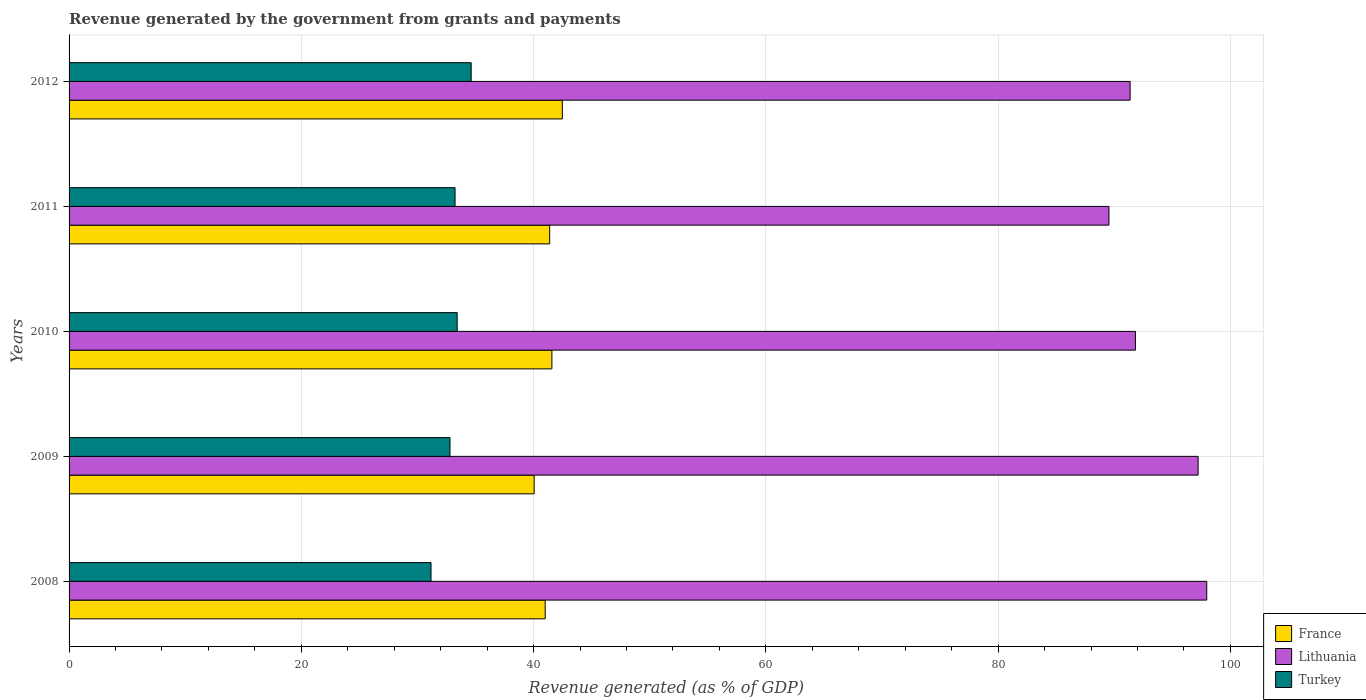How many groups of bars are there?
Give a very brief answer. 5. Are the number of bars per tick equal to the number of legend labels?
Give a very brief answer. Yes. Are the number of bars on each tick of the Y-axis equal?
Ensure brevity in your answer.  Yes. How many bars are there on the 5th tick from the top?
Offer a terse response. 3. What is the label of the 4th group of bars from the top?
Offer a terse response. 2009. In how many cases, is the number of bars for a given year not equal to the number of legend labels?
Keep it short and to the point. 0. What is the revenue generated by the government in France in 2010?
Offer a terse response. 41.57. Across all years, what is the maximum revenue generated by the government in Turkey?
Offer a very short reply. 34.62. Across all years, what is the minimum revenue generated by the government in Turkey?
Ensure brevity in your answer.  31.17. In which year was the revenue generated by the government in France maximum?
Your answer should be very brief. 2012. What is the total revenue generated by the government in Lithuania in the graph?
Give a very brief answer. 467.91. What is the difference between the revenue generated by the government in Lithuania in 2009 and that in 2011?
Ensure brevity in your answer.  7.68. What is the difference between the revenue generated by the government in Turkey in 2009 and the revenue generated by the government in Lithuania in 2011?
Provide a short and direct response. -56.74. What is the average revenue generated by the government in Turkey per year?
Make the answer very short. 33.05. In the year 2012, what is the difference between the revenue generated by the government in Lithuania and revenue generated by the government in Turkey?
Offer a terse response. 56.74. What is the ratio of the revenue generated by the government in Turkey in 2010 to that in 2012?
Make the answer very short. 0.97. What is the difference between the highest and the second highest revenue generated by the government in France?
Offer a terse response. 0.9. What is the difference between the highest and the lowest revenue generated by the government in France?
Your response must be concise. 2.43. In how many years, is the revenue generated by the government in Lithuania greater than the average revenue generated by the government in Lithuania taken over all years?
Make the answer very short. 2. What does the 2nd bar from the bottom in 2011 represents?
Your answer should be very brief. Lithuania. How many bars are there?
Offer a very short reply. 15. Are all the bars in the graph horizontal?
Make the answer very short. Yes. How many years are there in the graph?
Offer a terse response. 5. Where does the legend appear in the graph?
Give a very brief answer. Bottom right. What is the title of the graph?
Provide a succinct answer. Revenue generated by the government from grants and payments. Does "Nepal" appear as one of the legend labels in the graph?
Keep it short and to the point. No. What is the label or title of the X-axis?
Offer a terse response. Revenue generated (as % of GDP). What is the label or title of the Y-axis?
Provide a succinct answer. Years. What is the Revenue generated (as % of GDP) of France in 2008?
Provide a succinct answer. 41. What is the Revenue generated (as % of GDP) in Lithuania in 2008?
Your answer should be very brief. 97.96. What is the Revenue generated (as % of GDP) of Turkey in 2008?
Ensure brevity in your answer.  31.17. What is the Revenue generated (as % of GDP) in France in 2009?
Provide a succinct answer. 40.05. What is the Revenue generated (as % of GDP) in Lithuania in 2009?
Offer a very short reply. 97.22. What is the Revenue generated (as % of GDP) in Turkey in 2009?
Provide a short and direct response. 32.8. What is the Revenue generated (as % of GDP) in France in 2010?
Offer a terse response. 41.57. What is the Revenue generated (as % of GDP) in Lithuania in 2010?
Offer a very short reply. 91.82. What is the Revenue generated (as % of GDP) of Turkey in 2010?
Give a very brief answer. 33.42. What is the Revenue generated (as % of GDP) of France in 2011?
Provide a succinct answer. 41.38. What is the Revenue generated (as % of GDP) in Lithuania in 2011?
Ensure brevity in your answer.  89.54. What is the Revenue generated (as % of GDP) in Turkey in 2011?
Offer a terse response. 33.23. What is the Revenue generated (as % of GDP) in France in 2012?
Offer a very short reply. 42.47. What is the Revenue generated (as % of GDP) of Lithuania in 2012?
Provide a short and direct response. 91.36. What is the Revenue generated (as % of GDP) in Turkey in 2012?
Provide a short and direct response. 34.62. Across all years, what is the maximum Revenue generated (as % of GDP) of France?
Your answer should be compact. 42.47. Across all years, what is the maximum Revenue generated (as % of GDP) in Lithuania?
Make the answer very short. 97.96. Across all years, what is the maximum Revenue generated (as % of GDP) in Turkey?
Your response must be concise. 34.62. Across all years, what is the minimum Revenue generated (as % of GDP) in France?
Your answer should be very brief. 40.05. Across all years, what is the minimum Revenue generated (as % of GDP) in Lithuania?
Make the answer very short. 89.54. Across all years, what is the minimum Revenue generated (as % of GDP) in Turkey?
Provide a short and direct response. 31.17. What is the total Revenue generated (as % of GDP) of France in the graph?
Offer a terse response. 206.47. What is the total Revenue generated (as % of GDP) of Lithuania in the graph?
Your answer should be compact. 467.91. What is the total Revenue generated (as % of GDP) of Turkey in the graph?
Provide a succinct answer. 165.24. What is the difference between the Revenue generated (as % of GDP) in France in 2008 and that in 2009?
Make the answer very short. 0.95. What is the difference between the Revenue generated (as % of GDP) in Lithuania in 2008 and that in 2009?
Your response must be concise. 0.74. What is the difference between the Revenue generated (as % of GDP) of Turkey in 2008 and that in 2009?
Your response must be concise. -1.63. What is the difference between the Revenue generated (as % of GDP) of France in 2008 and that in 2010?
Your answer should be very brief. -0.58. What is the difference between the Revenue generated (as % of GDP) in Lithuania in 2008 and that in 2010?
Offer a terse response. 6.14. What is the difference between the Revenue generated (as % of GDP) of Turkey in 2008 and that in 2010?
Offer a very short reply. -2.25. What is the difference between the Revenue generated (as % of GDP) in France in 2008 and that in 2011?
Ensure brevity in your answer.  -0.38. What is the difference between the Revenue generated (as % of GDP) in Lithuania in 2008 and that in 2011?
Offer a very short reply. 8.42. What is the difference between the Revenue generated (as % of GDP) in Turkey in 2008 and that in 2011?
Provide a succinct answer. -2.07. What is the difference between the Revenue generated (as % of GDP) of France in 2008 and that in 2012?
Ensure brevity in your answer.  -1.47. What is the difference between the Revenue generated (as % of GDP) in Lithuania in 2008 and that in 2012?
Make the answer very short. 6.6. What is the difference between the Revenue generated (as % of GDP) of Turkey in 2008 and that in 2012?
Ensure brevity in your answer.  -3.46. What is the difference between the Revenue generated (as % of GDP) of France in 2009 and that in 2010?
Provide a short and direct response. -1.53. What is the difference between the Revenue generated (as % of GDP) of Lithuania in 2009 and that in 2010?
Provide a succinct answer. 5.4. What is the difference between the Revenue generated (as % of GDP) in Turkey in 2009 and that in 2010?
Your response must be concise. -0.62. What is the difference between the Revenue generated (as % of GDP) of France in 2009 and that in 2011?
Your answer should be very brief. -1.34. What is the difference between the Revenue generated (as % of GDP) in Lithuania in 2009 and that in 2011?
Offer a very short reply. 7.68. What is the difference between the Revenue generated (as % of GDP) of Turkey in 2009 and that in 2011?
Provide a succinct answer. -0.44. What is the difference between the Revenue generated (as % of GDP) in France in 2009 and that in 2012?
Ensure brevity in your answer.  -2.43. What is the difference between the Revenue generated (as % of GDP) of Lithuania in 2009 and that in 2012?
Ensure brevity in your answer.  5.86. What is the difference between the Revenue generated (as % of GDP) in Turkey in 2009 and that in 2012?
Offer a very short reply. -1.82. What is the difference between the Revenue generated (as % of GDP) in France in 2010 and that in 2011?
Ensure brevity in your answer.  0.19. What is the difference between the Revenue generated (as % of GDP) in Lithuania in 2010 and that in 2011?
Ensure brevity in your answer.  2.28. What is the difference between the Revenue generated (as % of GDP) of Turkey in 2010 and that in 2011?
Ensure brevity in your answer.  0.18. What is the difference between the Revenue generated (as % of GDP) of France in 2010 and that in 2012?
Ensure brevity in your answer.  -0.9. What is the difference between the Revenue generated (as % of GDP) of Lithuania in 2010 and that in 2012?
Make the answer very short. 0.46. What is the difference between the Revenue generated (as % of GDP) of Turkey in 2010 and that in 2012?
Offer a very short reply. -1.2. What is the difference between the Revenue generated (as % of GDP) of France in 2011 and that in 2012?
Your answer should be compact. -1.09. What is the difference between the Revenue generated (as % of GDP) of Lithuania in 2011 and that in 2012?
Keep it short and to the point. -1.82. What is the difference between the Revenue generated (as % of GDP) of Turkey in 2011 and that in 2012?
Your answer should be very brief. -1.39. What is the difference between the Revenue generated (as % of GDP) in France in 2008 and the Revenue generated (as % of GDP) in Lithuania in 2009?
Keep it short and to the point. -56.22. What is the difference between the Revenue generated (as % of GDP) of France in 2008 and the Revenue generated (as % of GDP) of Turkey in 2009?
Your answer should be compact. 8.2. What is the difference between the Revenue generated (as % of GDP) in Lithuania in 2008 and the Revenue generated (as % of GDP) in Turkey in 2009?
Keep it short and to the point. 65.16. What is the difference between the Revenue generated (as % of GDP) of France in 2008 and the Revenue generated (as % of GDP) of Lithuania in 2010?
Provide a short and direct response. -50.82. What is the difference between the Revenue generated (as % of GDP) of France in 2008 and the Revenue generated (as % of GDP) of Turkey in 2010?
Provide a succinct answer. 7.58. What is the difference between the Revenue generated (as % of GDP) in Lithuania in 2008 and the Revenue generated (as % of GDP) in Turkey in 2010?
Offer a terse response. 64.54. What is the difference between the Revenue generated (as % of GDP) of France in 2008 and the Revenue generated (as % of GDP) of Lithuania in 2011?
Make the answer very short. -48.54. What is the difference between the Revenue generated (as % of GDP) of France in 2008 and the Revenue generated (as % of GDP) of Turkey in 2011?
Your answer should be compact. 7.76. What is the difference between the Revenue generated (as % of GDP) of Lithuania in 2008 and the Revenue generated (as % of GDP) of Turkey in 2011?
Provide a short and direct response. 64.73. What is the difference between the Revenue generated (as % of GDP) of France in 2008 and the Revenue generated (as % of GDP) of Lithuania in 2012?
Offer a terse response. -50.37. What is the difference between the Revenue generated (as % of GDP) of France in 2008 and the Revenue generated (as % of GDP) of Turkey in 2012?
Make the answer very short. 6.37. What is the difference between the Revenue generated (as % of GDP) in Lithuania in 2008 and the Revenue generated (as % of GDP) in Turkey in 2012?
Make the answer very short. 63.34. What is the difference between the Revenue generated (as % of GDP) in France in 2009 and the Revenue generated (as % of GDP) in Lithuania in 2010?
Provide a succinct answer. -51.78. What is the difference between the Revenue generated (as % of GDP) in France in 2009 and the Revenue generated (as % of GDP) in Turkey in 2010?
Your answer should be very brief. 6.63. What is the difference between the Revenue generated (as % of GDP) of Lithuania in 2009 and the Revenue generated (as % of GDP) of Turkey in 2010?
Your answer should be compact. 63.8. What is the difference between the Revenue generated (as % of GDP) in France in 2009 and the Revenue generated (as % of GDP) in Lithuania in 2011?
Make the answer very short. -49.49. What is the difference between the Revenue generated (as % of GDP) in France in 2009 and the Revenue generated (as % of GDP) in Turkey in 2011?
Ensure brevity in your answer.  6.81. What is the difference between the Revenue generated (as % of GDP) of Lithuania in 2009 and the Revenue generated (as % of GDP) of Turkey in 2011?
Your answer should be compact. 63.98. What is the difference between the Revenue generated (as % of GDP) in France in 2009 and the Revenue generated (as % of GDP) in Lithuania in 2012?
Provide a short and direct response. -51.32. What is the difference between the Revenue generated (as % of GDP) of France in 2009 and the Revenue generated (as % of GDP) of Turkey in 2012?
Your answer should be very brief. 5.42. What is the difference between the Revenue generated (as % of GDP) of Lithuania in 2009 and the Revenue generated (as % of GDP) of Turkey in 2012?
Keep it short and to the point. 62.6. What is the difference between the Revenue generated (as % of GDP) of France in 2010 and the Revenue generated (as % of GDP) of Lithuania in 2011?
Provide a short and direct response. -47.97. What is the difference between the Revenue generated (as % of GDP) of France in 2010 and the Revenue generated (as % of GDP) of Turkey in 2011?
Provide a short and direct response. 8.34. What is the difference between the Revenue generated (as % of GDP) in Lithuania in 2010 and the Revenue generated (as % of GDP) in Turkey in 2011?
Provide a short and direct response. 58.59. What is the difference between the Revenue generated (as % of GDP) in France in 2010 and the Revenue generated (as % of GDP) in Lithuania in 2012?
Give a very brief answer. -49.79. What is the difference between the Revenue generated (as % of GDP) of France in 2010 and the Revenue generated (as % of GDP) of Turkey in 2012?
Offer a very short reply. 6.95. What is the difference between the Revenue generated (as % of GDP) in Lithuania in 2010 and the Revenue generated (as % of GDP) in Turkey in 2012?
Make the answer very short. 57.2. What is the difference between the Revenue generated (as % of GDP) of France in 2011 and the Revenue generated (as % of GDP) of Lithuania in 2012?
Provide a short and direct response. -49.98. What is the difference between the Revenue generated (as % of GDP) of France in 2011 and the Revenue generated (as % of GDP) of Turkey in 2012?
Make the answer very short. 6.76. What is the difference between the Revenue generated (as % of GDP) in Lithuania in 2011 and the Revenue generated (as % of GDP) in Turkey in 2012?
Offer a terse response. 54.92. What is the average Revenue generated (as % of GDP) in France per year?
Provide a succinct answer. 41.3. What is the average Revenue generated (as % of GDP) of Lithuania per year?
Keep it short and to the point. 93.58. What is the average Revenue generated (as % of GDP) of Turkey per year?
Provide a short and direct response. 33.05. In the year 2008, what is the difference between the Revenue generated (as % of GDP) of France and Revenue generated (as % of GDP) of Lithuania?
Keep it short and to the point. -56.96. In the year 2008, what is the difference between the Revenue generated (as % of GDP) in France and Revenue generated (as % of GDP) in Turkey?
Offer a terse response. 9.83. In the year 2008, what is the difference between the Revenue generated (as % of GDP) of Lithuania and Revenue generated (as % of GDP) of Turkey?
Ensure brevity in your answer.  66.79. In the year 2009, what is the difference between the Revenue generated (as % of GDP) in France and Revenue generated (as % of GDP) in Lithuania?
Provide a succinct answer. -57.17. In the year 2009, what is the difference between the Revenue generated (as % of GDP) of France and Revenue generated (as % of GDP) of Turkey?
Your answer should be compact. 7.25. In the year 2009, what is the difference between the Revenue generated (as % of GDP) of Lithuania and Revenue generated (as % of GDP) of Turkey?
Your answer should be compact. 64.42. In the year 2010, what is the difference between the Revenue generated (as % of GDP) of France and Revenue generated (as % of GDP) of Lithuania?
Offer a terse response. -50.25. In the year 2010, what is the difference between the Revenue generated (as % of GDP) of France and Revenue generated (as % of GDP) of Turkey?
Ensure brevity in your answer.  8.15. In the year 2010, what is the difference between the Revenue generated (as % of GDP) of Lithuania and Revenue generated (as % of GDP) of Turkey?
Make the answer very short. 58.4. In the year 2011, what is the difference between the Revenue generated (as % of GDP) in France and Revenue generated (as % of GDP) in Lithuania?
Your answer should be compact. -48.16. In the year 2011, what is the difference between the Revenue generated (as % of GDP) of France and Revenue generated (as % of GDP) of Turkey?
Offer a very short reply. 8.15. In the year 2011, what is the difference between the Revenue generated (as % of GDP) in Lithuania and Revenue generated (as % of GDP) in Turkey?
Offer a terse response. 56.31. In the year 2012, what is the difference between the Revenue generated (as % of GDP) in France and Revenue generated (as % of GDP) in Lithuania?
Offer a very short reply. -48.89. In the year 2012, what is the difference between the Revenue generated (as % of GDP) in France and Revenue generated (as % of GDP) in Turkey?
Your response must be concise. 7.85. In the year 2012, what is the difference between the Revenue generated (as % of GDP) in Lithuania and Revenue generated (as % of GDP) in Turkey?
Offer a very short reply. 56.74. What is the ratio of the Revenue generated (as % of GDP) of France in 2008 to that in 2009?
Keep it short and to the point. 1.02. What is the ratio of the Revenue generated (as % of GDP) of Lithuania in 2008 to that in 2009?
Give a very brief answer. 1.01. What is the ratio of the Revenue generated (as % of GDP) of Turkey in 2008 to that in 2009?
Provide a succinct answer. 0.95. What is the ratio of the Revenue generated (as % of GDP) of France in 2008 to that in 2010?
Make the answer very short. 0.99. What is the ratio of the Revenue generated (as % of GDP) of Lithuania in 2008 to that in 2010?
Ensure brevity in your answer.  1.07. What is the ratio of the Revenue generated (as % of GDP) in Turkey in 2008 to that in 2010?
Offer a very short reply. 0.93. What is the ratio of the Revenue generated (as % of GDP) in Lithuania in 2008 to that in 2011?
Your answer should be compact. 1.09. What is the ratio of the Revenue generated (as % of GDP) in Turkey in 2008 to that in 2011?
Your answer should be very brief. 0.94. What is the ratio of the Revenue generated (as % of GDP) in France in 2008 to that in 2012?
Offer a terse response. 0.97. What is the ratio of the Revenue generated (as % of GDP) of Lithuania in 2008 to that in 2012?
Offer a terse response. 1.07. What is the ratio of the Revenue generated (as % of GDP) of Turkey in 2008 to that in 2012?
Your answer should be very brief. 0.9. What is the ratio of the Revenue generated (as % of GDP) of France in 2009 to that in 2010?
Give a very brief answer. 0.96. What is the ratio of the Revenue generated (as % of GDP) of Lithuania in 2009 to that in 2010?
Your response must be concise. 1.06. What is the ratio of the Revenue generated (as % of GDP) in Turkey in 2009 to that in 2010?
Your answer should be compact. 0.98. What is the ratio of the Revenue generated (as % of GDP) of Lithuania in 2009 to that in 2011?
Your response must be concise. 1.09. What is the ratio of the Revenue generated (as % of GDP) of Turkey in 2009 to that in 2011?
Provide a succinct answer. 0.99. What is the ratio of the Revenue generated (as % of GDP) of France in 2009 to that in 2012?
Offer a terse response. 0.94. What is the ratio of the Revenue generated (as % of GDP) in Lithuania in 2009 to that in 2012?
Give a very brief answer. 1.06. What is the ratio of the Revenue generated (as % of GDP) of Turkey in 2009 to that in 2012?
Offer a terse response. 0.95. What is the ratio of the Revenue generated (as % of GDP) of France in 2010 to that in 2011?
Offer a terse response. 1. What is the ratio of the Revenue generated (as % of GDP) in Lithuania in 2010 to that in 2011?
Provide a short and direct response. 1.03. What is the ratio of the Revenue generated (as % of GDP) in Turkey in 2010 to that in 2011?
Your answer should be compact. 1.01. What is the ratio of the Revenue generated (as % of GDP) in France in 2010 to that in 2012?
Your answer should be compact. 0.98. What is the ratio of the Revenue generated (as % of GDP) of Turkey in 2010 to that in 2012?
Provide a succinct answer. 0.97. What is the ratio of the Revenue generated (as % of GDP) of France in 2011 to that in 2012?
Offer a very short reply. 0.97. What is the ratio of the Revenue generated (as % of GDP) in Lithuania in 2011 to that in 2012?
Your answer should be very brief. 0.98. What is the ratio of the Revenue generated (as % of GDP) of Turkey in 2011 to that in 2012?
Make the answer very short. 0.96. What is the difference between the highest and the second highest Revenue generated (as % of GDP) of France?
Make the answer very short. 0.9. What is the difference between the highest and the second highest Revenue generated (as % of GDP) of Lithuania?
Ensure brevity in your answer.  0.74. What is the difference between the highest and the second highest Revenue generated (as % of GDP) of Turkey?
Ensure brevity in your answer.  1.2. What is the difference between the highest and the lowest Revenue generated (as % of GDP) in France?
Provide a short and direct response. 2.43. What is the difference between the highest and the lowest Revenue generated (as % of GDP) in Lithuania?
Make the answer very short. 8.42. What is the difference between the highest and the lowest Revenue generated (as % of GDP) of Turkey?
Provide a succinct answer. 3.46. 